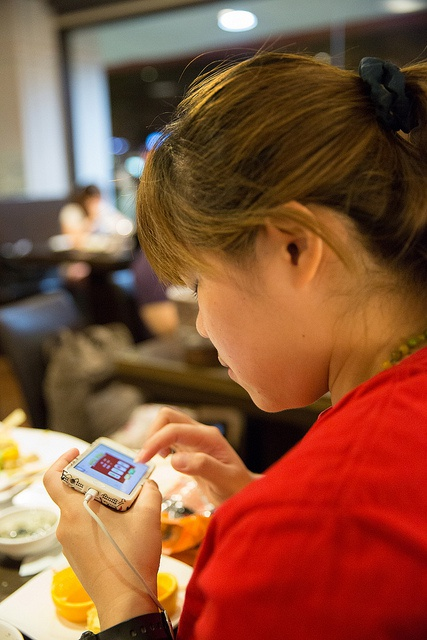Describe the objects in this image and their specific colors. I can see people in black, maroon, brown, and red tones, chair in black and gray tones, people in black, lightgray, tan, and gray tones, cell phone in black, beige, tan, and lightblue tones, and chair in black and gray tones in this image. 